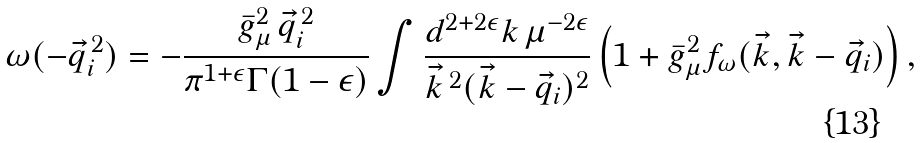<formula> <loc_0><loc_0><loc_500><loc_500>\omega ( - \vec { q } _ { i } ^ { \, 2 } ) = - \frac { \bar { g } _ { \mu } ^ { 2 } \, \vec { q } _ { i } ^ { \, 2 } } { \pi ^ { 1 + \epsilon } \Gamma ( 1 - \epsilon ) } \int \frac { d ^ { 2 + 2 \epsilon } k \, \mu ^ { - 2 \epsilon } } { \vec { k } ^ { \, 2 } ( \vec { k } - \vec { q } _ { i } ) ^ { 2 } } \left ( 1 + \bar { g } _ { \mu } ^ { 2 } f _ { \omega } ( \vec { k } , \vec { k } - \vec { q } _ { i } ) \right ) ,</formula> 